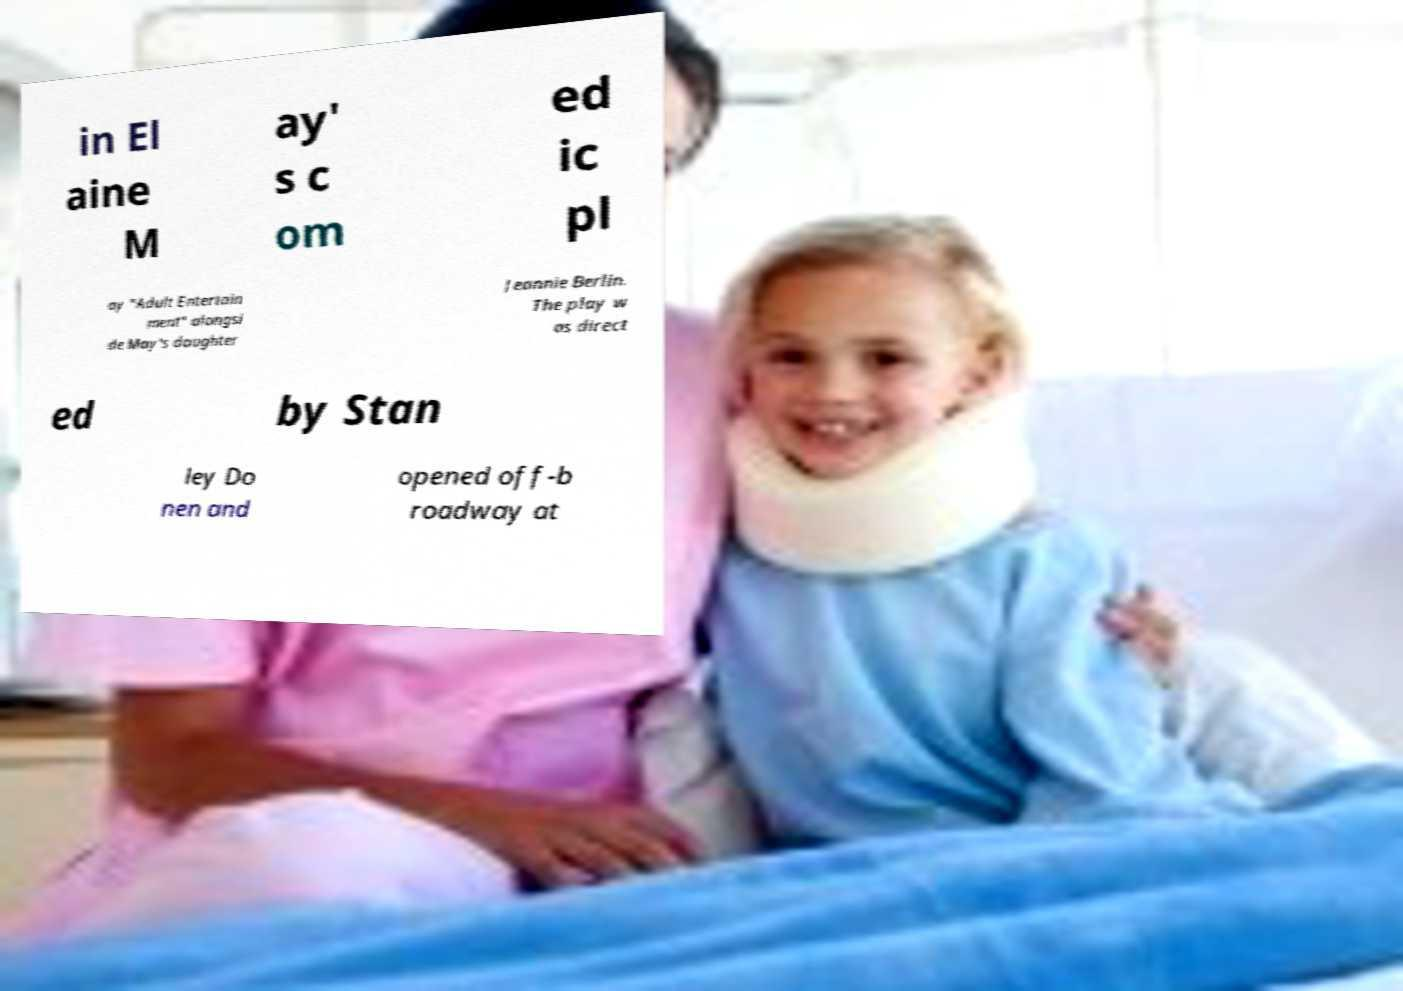Please read and relay the text visible in this image. What does it say? in El aine M ay' s c om ed ic pl ay "Adult Entertain ment" alongsi de May's daughter Jeannie Berlin. The play w as direct ed by Stan ley Do nen and opened off-b roadway at 